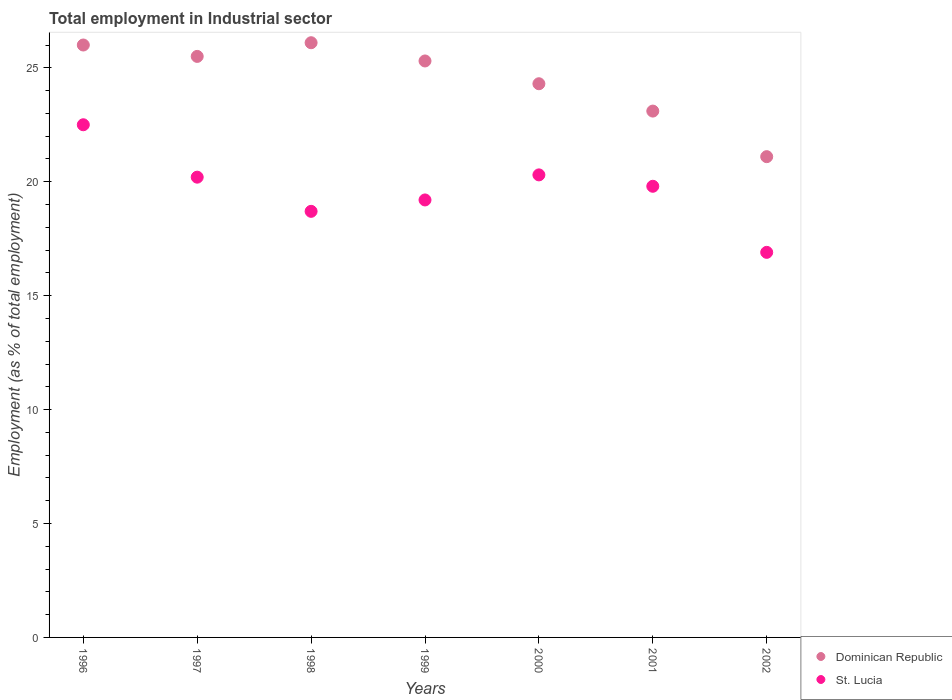How many different coloured dotlines are there?
Ensure brevity in your answer.  2. What is the employment in industrial sector in Dominican Republic in 1997?
Provide a succinct answer. 25.5. Across all years, what is the maximum employment in industrial sector in Dominican Republic?
Make the answer very short. 26.1. Across all years, what is the minimum employment in industrial sector in Dominican Republic?
Give a very brief answer. 21.1. In which year was the employment in industrial sector in Dominican Republic minimum?
Offer a very short reply. 2002. What is the total employment in industrial sector in Dominican Republic in the graph?
Offer a terse response. 171.4. What is the difference between the employment in industrial sector in St. Lucia in 1996 and that in 2002?
Provide a succinct answer. 5.6. What is the difference between the employment in industrial sector in St. Lucia in 1999 and the employment in industrial sector in Dominican Republic in 2000?
Ensure brevity in your answer.  -5.1. What is the average employment in industrial sector in Dominican Republic per year?
Provide a succinct answer. 24.49. In the year 2001, what is the difference between the employment in industrial sector in St. Lucia and employment in industrial sector in Dominican Republic?
Make the answer very short. -3.3. What is the ratio of the employment in industrial sector in Dominican Republic in 1998 to that in 2000?
Ensure brevity in your answer.  1.07. Is the difference between the employment in industrial sector in St. Lucia in 2001 and 2002 greater than the difference between the employment in industrial sector in Dominican Republic in 2001 and 2002?
Your response must be concise. Yes. What is the difference between the highest and the second highest employment in industrial sector in Dominican Republic?
Make the answer very short. 0.1. What is the difference between the highest and the lowest employment in industrial sector in Dominican Republic?
Offer a very short reply. 5. Does the employment in industrial sector in St. Lucia monotonically increase over the years?
Offer a terse response. No. Is the employment in industrial sector in St. Lucia strictly greater than the employment in industrial sector in Dominican Republic over the years?
Provide a succinct answer. No. How many years are there in the graph?
Your response must be concise. 7. Are the values on the major ticks of Y-axis written in scientific E-notation?
Ensure brevity in your answer.  No. Does the graph contain grids?
Your answer should be very brief. No. What is the title of the graph?
Keep it short and to the point. Total employment in Industrial sector. What is the label or title of the Y-axis?
Your answer should be very brief. Employment (as % of total employment). What is the Employment (as % of total employment) in St. Lucia in 1996?
Ensure brevity in your answer.  22.5. What is the Employment (as % of total employment) in Dominican Republic in 1997?
Your answer should be compact. 25.5. What is the Employment (as % of total employment) of St. Lucia in 1997?
Keep it short and to the point. 20.2. What is the Employment (as % of total employment) in Dominican Republic in 1998?
Make the answer very short. 26.1. What is the Employment (as % of total employment) in St. Lucia in 1998?
Your answer should be very brief. 18.7. What is the Employment (as % of total employment) in Dominican Republic in 1999?
Your answer should be compact. 25.3. What is the Employment (as % of total employment) of St. Lucia in 1999?
Provide a short and direct response. 19.2. What is the Employment (as % of total employment) in Dominican Republic in 2000?
Your response must be concise. 24.3. What is the Employment (as % of total employment) of St. Lucia in 2000?
Ensure brevity in your answer.  20.3. What is the Employment (as % of total employment) in Dominican Republic in 2001?
Give a very brief answer. 23.1. What is the Employment (as % of total employment) of St. Lucia in 2001?
Make the answer very short. 19.8. What is the Employment (as % of total employment) of Dominican Republic in 2002?
Your answer should be very brief. 21.1. What is the Employment (as % of total employment) in St. Lucia in 2002?
Offer a terse response. 16.9. Across all years, what is the maximum Employment (as % of total employment) of Dominican Republic?
Provide a succinct answer. 26.1. Across all years, what is the minimum Employment (as % of total employment) of Dominican Republic?
Offer a terse response. 21.1. Across all years, what is the minimum Employment (as % of total employment) of St. Lucia?
Your response must be concise. 16.9. What is the total Employment (as % of total employment) of Dominican Republic in the graph?
Your response must be concise. 171.4. What is the total Employment (as % of total employment) in St. Lucia in the graph?
Your answer should be compact. 137.6. What is the difference between the Employment (as % of total employment) in Dominican Republic in 1996 and that in 1997?
Keep it short and to the point. 0.5. What is the difference between the Employment (as % of total employment) in Dominican Republic in 1996 and that in 1998?
Give a very brief answer. -0.1. What is the difference between the Employment (as % of total employment) in Dominican Republic in 1996 and that in 1999?
Your answer should be very brief. 0.7. What is the difference between the Employment (as % of total employment) in St. Lucia in 1996 and that in 1999?
Your answer should be compact. 3.3. What is the difference between the Employment (as % of total employment) in Dominican Republic in 1996 and that in 2001?
Offer a very short reply. 2.9. What is the difference between the Employment (as % of total employment) of St. Lucia in 1996 and that in 2001?
Your answer should be very brief. 2.7. What is the difference between the Employment (as % of total employment) of Dominican Republic in 1996 and that in 2002?
Provide a short and direct response. 4.9. What is the difference between the Employment (as % of total employment) in St. Lucia in 1997 and that in 1998?
Offer a terse response. 1.5. What is the difference between the Employment (as % of total employment) in Dominican Republic in 1997 and that in 1999?
Give a very brief answer. 0.2. What is the difference between the Employment (as % of total employment) in Dominican Republic in 1997 and that in 2000?
Ensure brevity in your answer.  1.2. What is the difference between the Employment (as % of total employment) in St. Lucia in 1997 and that in 2000?
Your answer should be very brief. -0.1. What is the difference between the Employment (as % of total employment) in Dominican Republic in 1998 and that in 1999?
Give a very brief answer. 0.8. What is the difference between the Employment (as % of total employment) of St. Lucia in 1998 and that in 1999?
Make the answer very short. -0.5. What is the difference between the Employment (as % of total employment) in St. Lucia in 1998 and that in 2000?
Make the answer very short. -1.6. What is the difference between the Employment (as % of total employment) in St. Lucia in 1998 and that in 2001?
Offer a terse response. -1.1. What is the difference between the Employment (as % of total employment) in Dominican Republic in 1999 and that in 2000?
Make the answer very short. 1. What is the difference between the Employment (as % of total employment) of Dominican Republic in 1999 and that in 2001?
Your answer should be compact. 2.2. What is the difference between the Employment (as % of total employment) of St. Lucia in 1999 and that in 2001?
Provide a succinct answer. -0.6. What is the difference between the Employment (as % of total employment) of Dominican Republic in 1999 and that in 2002?
Provide a short and direct response. 4.2. What is the difference between the Employment (as % of total employment) of Dominican Republic in 2000 and that in 2001?
Offer a terse response. 1.2. What is the difference between the Employment (as % of total employment) of St. Lucia in 2000 and that in 2001?
Keep it short and to the point. 0.5. What is the difference between the Employment (as % of total employment) in Dominican Republic in 2000 and that in 2002?
Provide a succinct answer. 3.2. What is the difference between the Employment (as % of total employment) of Dominican Republic in 1997 and the Employment (as % of total employment) of St. Lucia in 1998?
Your response must be concise. 6.8. What is the difference between the Employment (as % of total employment) of Dominican Republic in 1997 and the Employment (as % of total employment) of St. Lucia in 2000?
Your answer should be very brief. 5.2. What is the difference between the Employment (as % of total employment) of Dominican Republic in 1997 and the Employment (as % of total employment) of St. Lucia in 2001?
Offer a very short reply. 5.7. What is the difference between the Employment (as % of total employment) of Dominican Republic in 1998 and the Employment (as % of total employment) of St. Lucia in 1999?
Provide a succinct answer. 6.9. What is the difference between the Employment (as % of total employment) of Dominican Republic in 1998 and the Employment (as % of total employment) of St. Lucia in 2001?
Offer a terse response. 6.3. What is the difference between the Employment (as % of total employment) of Dominican Republic in 2000 and the Employment (as % of total employment) of St. Lucia in 2001?
Ensure brevity in your answer.  4.5. What is the average Employment (as % of total employment) of Dominican Republic per year?
Make the answer very short. 24.49. What is the average Employment (as % of total employment) in St. Lucia per year?
Make the answer very short. 19.66. In the year 1997, what is the difference between the Employment (as % of total employment) in Dominican Republic and Employment (as % of total employment) in St. Lucia?
Give a very brief answer. 5.3. In the year 1998, what is the difference between the Employment (as % of total employment) of Dominican Republic and Employment (as % of total employment) of St. Lucia?
Provide a short and direct response. 7.4. In the year 2000, what is the difference between the Employment (as % of total employment) of Dominican Republic and Employment (as % of total employment) of St. Lucia?
Offer a very short reply. 4. In the year 2001, what is the difference between the Employment (as % of total employment) in Dominican Republic and Employment (as % of total employment) in St. Lucia?
Keep it short and to the point. 3.3. In the year 2002, what is the difference between the Employment (as % of total employment) of Dominican Republic and Employment (as % of total employment) of St. Lucia?
Your answer should be very brief. 4.2. What is the ratio of the Employment (as % of total employment) in Dominican Republic in 1996 to that in 1997?
Your response must be concise. 1.02. What is the ratio of the Employment (as % of total employment) of St. Lucia in 1996 to that in 1997?
Give a very brief answer. 1.11. What is the ratio of the Employment (as % of total employment) of St. Lucia in 1996 to that in 1998?
Make the answer very short. 1.2. What is the ratio of the Employment (as % of total employment) in Dominican Republic in 1996 to that in 1999?
Offer a very short reply. 1.03. What is the ratio of the Employment (as % of total employment) of St. Lucia in 1996 to that in 1999?
Your response must be concise. 1.17. What is the ratio of the Employment (as % of total employment) in Dominican Republic in 1996 to that in 2000?
Ensure brevity in your answer.  1.07. What is the ratio of the Employment (as % of total employment) of St. Lucia in 1996 to that in 2000?
Your answer should be very brief. 1.11. What is the ratio of the Employment (as % of total employment) of Dominican Republic in 1996 to that in 2001?
Give a very brief answer. 1.13. What is the ratio of the Employment (as % of total employment) of St. Lucia in 1996 to that in 2001?
Provide a succinct answer. 1.14. What is the ratio of the Employment (as % of total employment) in Dominican Republic in 1996 to that in 2002?
Ensure brevity in your answer.  1.23. What is the ratio of the Employment (as % of total employment) in St. Lucia in 1996 to that in 2002?
Keep it short and to the point. 1.33. What is the ratio of the Employment (as % of total employment) in St. Lucia in 1997 to that in 1998?
Offer a terse response. 1.08. What is the ratio of the Employment (as % of total employment) in Dominican Republic in 1997 to that in 1999?
Give a very brief answer. 1.01. What is the ratio of the Employment (as % of total employment) in St. Lucia in 1997 to that in 1999?
Your answer should be compact. 1.05. What is the ratio of the Employment (as % of total employment) of Dominican Republic in 1997 to that in 2000?
Keep it short and to the point. 1.05. What is the ratio of the Employment (as % of total employment) in St. Lucia in 1997 to that in 2000?
Your answer should be very brief. 1. What is the ratio of the Employment (as % of total employment) of Dominican Republic in 1997 to that in 2001?
Your answer should be compact. 1.1. What is the ratio of the Employment (as % of total employment) of St. Lucia in 1997 to that in 2001?
Offer a terse response. 1.02. What is the ratio of the Employment (as % of total employment) of Dominican Republic in 1997 to that in 2002?
Provide a succinct answer. 1.21. What is the ratio of the Employment (as % of total employment) of St. Lucia in 1997 to that in 2002?
Your answer should be very brief. 1.2. What is the ratio of the Employment (as % of total employment) of Dominican Republic in 1998 to that in 1999?
Your answer should be very brief. 1.03. What is the ratio of the Employment (as % of total employment) of Dominican Republic in 1998 to that in 2000?
Give a very brief answer. 1.07. What is the ratio of the Employment (as % of total employment) of St. Lucia in 1998 to that in 2000?
Provide a succinct answer. 0.92. What is the ratio of the Employment (as % of total employment) in Dominican Republic in 1998 to that in 2001?
Give a very brief answer. 1.13. What is the ratio of the Employment (as % of total employment) of St. Lucia in 1998 to that in 2001?
Offer a very short reply. 0.94. What is the ratio of the Employment (as % of total employment) of Dominican Republic in 1998 to that in 2002?
Your answer should be compact. 1.24. What is the ratio of the Employment (as % of total employment) of St. Lucia in 1998 to that in 2002?
Offer a terse response. 1.11. What is the ratio of the Employment (as % of total employment) in Dominican Republic in 1999 to that in 2000?
Provide a succinct answer. 1.04. What is the ratio of the Employment (as % of total employment) in St. Lucia in 1999 to that in 2000?
Provide a succinct answer. 0.95. What is the ratio of the Employment (as % of total employment) of Dominican Republic in 1999 to that in 2001?
Give a very brief answer. 1.1. What is the ratio of the Employment (as % of total employment) in St. Lucia in 1999 to that in 2001?
Your response must be concise. 0.97. What is the ratio of the Employment (as % of total employment) in Dominican Republic in 1999 to that in 2002?
Your response must be concise. 1.2. What is the ratio of the Employment (as % of total employment) in St. Lucia in 1999 to that in 2002?
Your answer should be very brief. 1.14. What is the ratio of the Employment (as % of total employment) in Dominican Republic in 2000 to that in 2001?
Your answer should be compact. 1.05. What is the ratio of the Employment (as % of total employment) of St. Lucia in 2000 to that in 2001?
Your response must be concise. 1.03. What is the ratio of the Employment (as % of total employment) in Dominican Republic in 2000 to that in 2002?
Your answer should be very brief. 1.15. What is the ratio of the Employment (as % of total employment) of St. Lucia in 2000 to that in 2002?
Your answer should be compact. 1.2. What is the ratio of the Employment (as % of total employment) in Dominican Republic in 2001 to that in 2002?
Keep it short and to the point. 1.09. What is the ratio of the Employment (as % of total employment) of St. Lucia in 2001 to that in 2002?
Give a very brief answer. 1.17. What is the difference between the highest and the second highest Employment (as % of total employment) in Dominican Republic?
Provide a succinct answer. 0.1. 